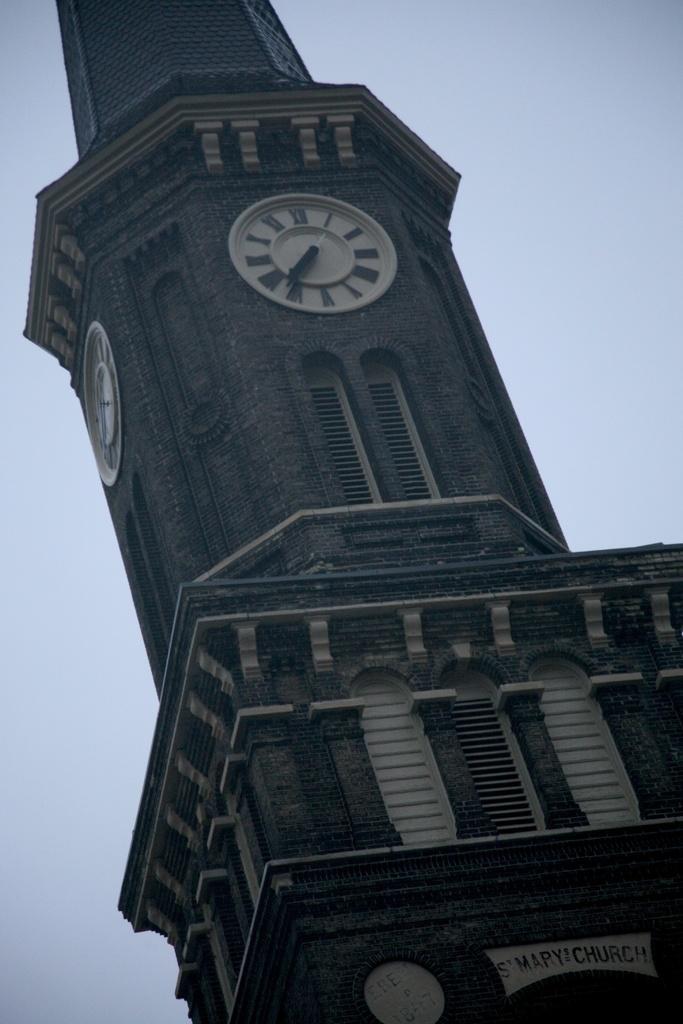Can you describe this image briefly? In this image, we can see a tower with clocks. We can see walls, windows and text on the tower. In the background, there is the sky. 